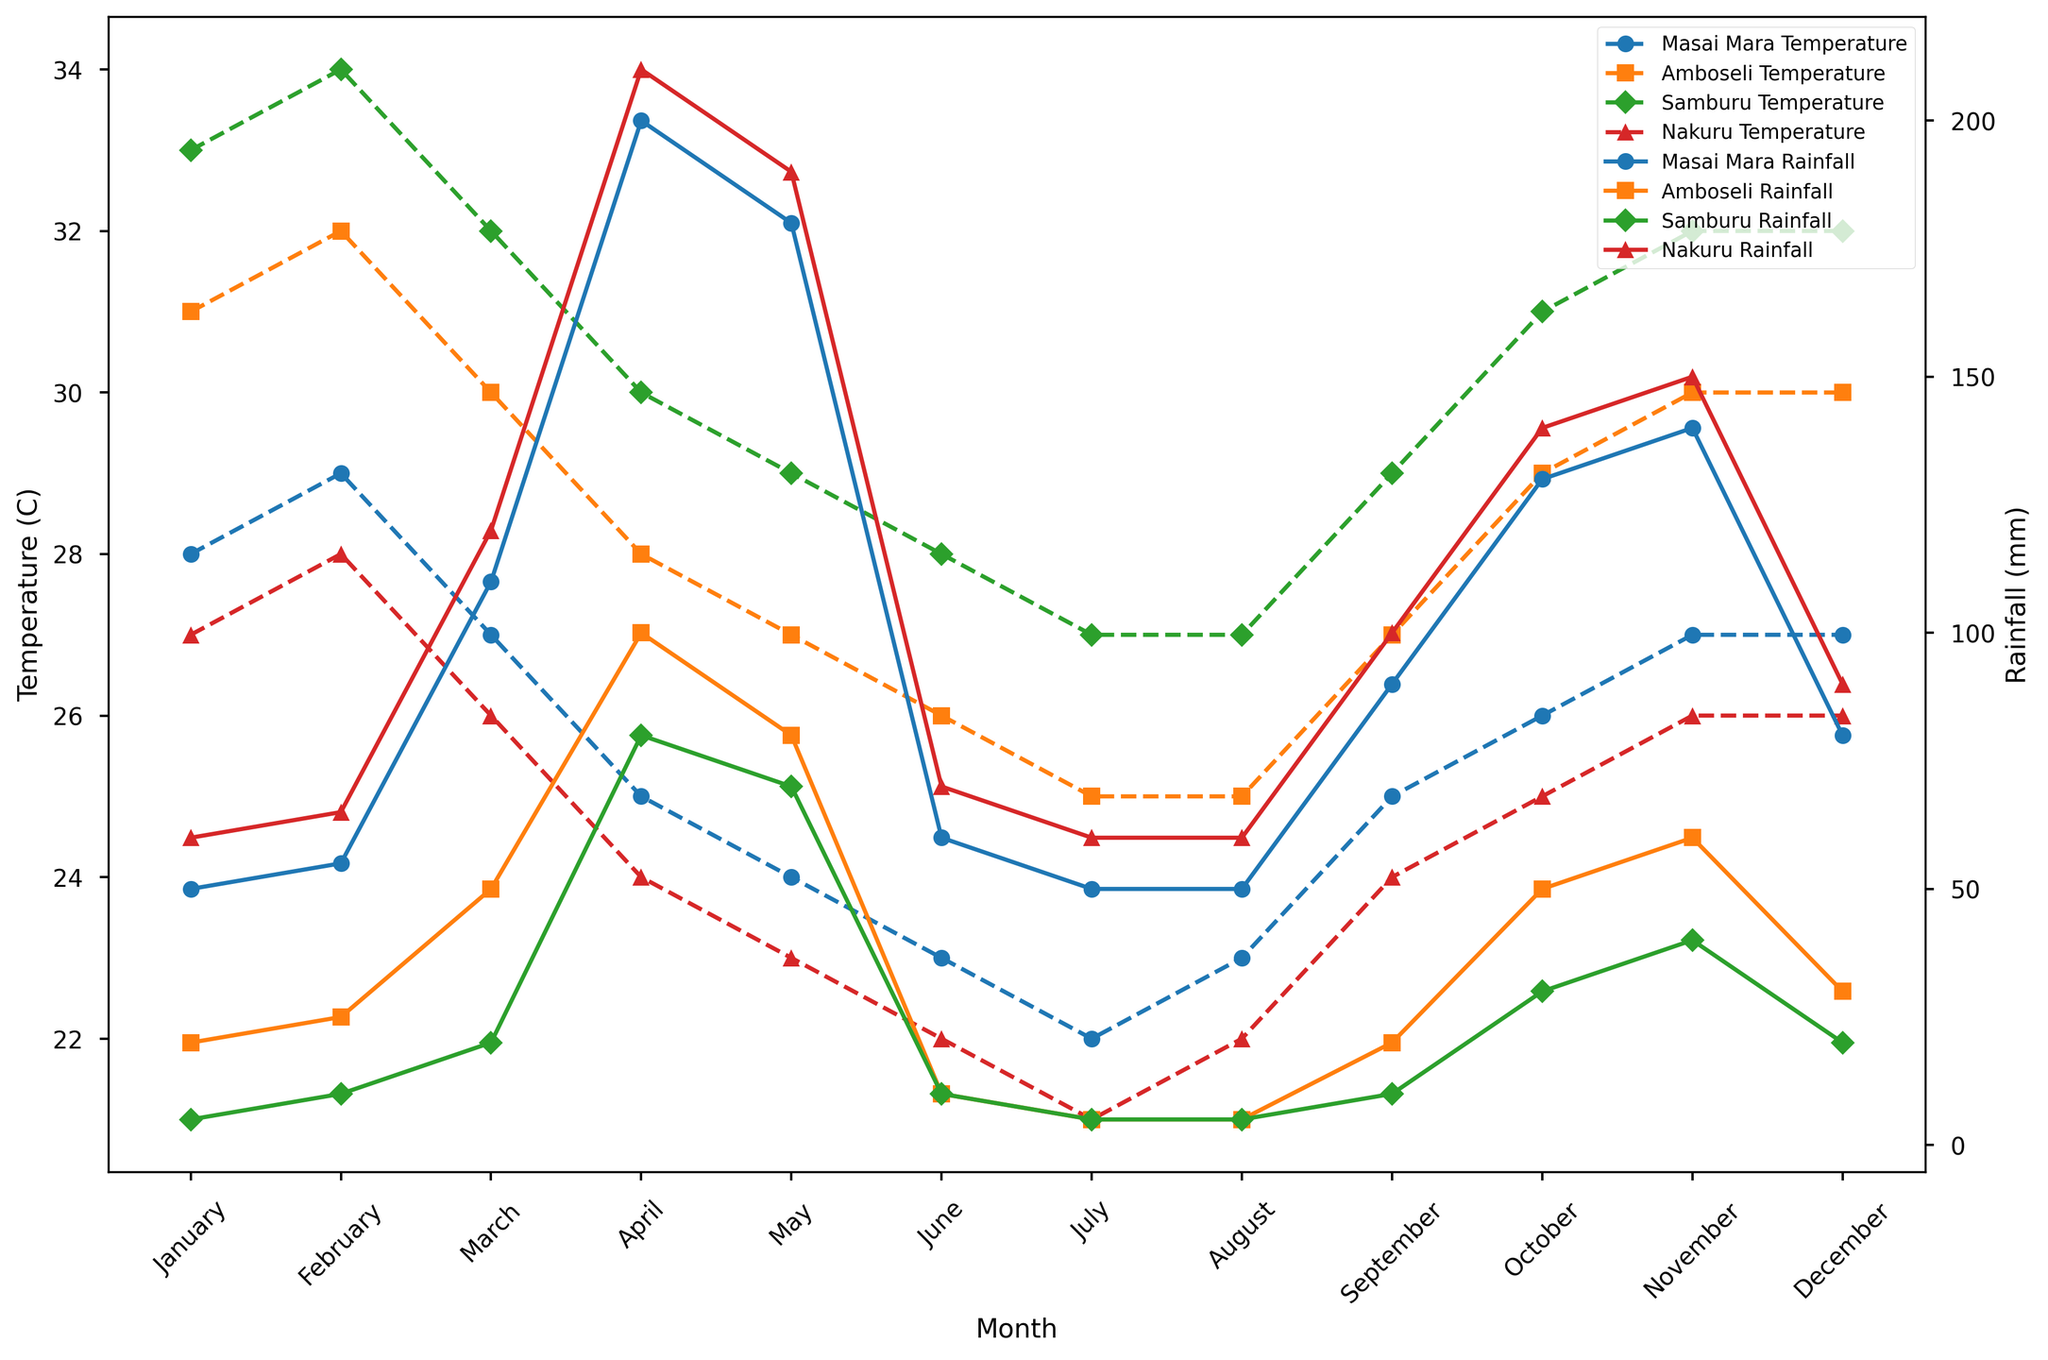What are the highest and lowest temperatures recorded in Masai Mara throughout the year? The highest temperature in Masai Mara is recorded in February at 29°C, and the lowest temperature is recorded in July at 22°C.
Answer: 29°C (highest), 22°C (lowest) Which month has the highest rainfall in Samburu? By observing the green line for Samburu, April has the highest rainfall at 80mm.
Answer: April Comparing June temperatures, which location is the hottest and which is the coolest? Look at June for all locations; Samburu is the hottest at 28°C, and Nakuru is the coolest at 22°C.
Answer: Samburu (hottest), Nakuru (coolest) What is the average rainfall in Amboseli from January to December? Sums up the rainfall values for each month in Amboseli (20 + 25 + 50 + 100 + 80 + 10 + 5 + 5 + 20 + 50 + 60 + 30) = 455mm. The average is 455/12 ≈ 37.92mm.
Answer: ≈ 37.92mm In which month does Nakuru experience the highest temperature and what is it? By observing the red line for Nakuru, February has the highest temperature at 28°C.
Answer: February, 28°C What is the difference in temperature between the hottest and coldest months in Masai Mara? The highest temperature in Masai Mara is 29°C (February) and the lowest is 22°C (July). The difference is 29 - 22 = 7°C.
Answer: 7°C How does the rainfall pattern in Nairobi compare to that in Amboseli during March and April? Comparing March and April, Nairobi has higher rainfall in both months (March: 120mm vs. 50mm, April: 210mm vs. 100mm).
Answer: Nairobi has higher rainfall What trend do you observe in temperatures in Samburu from June to September? The green line indicates temperatures steadily increase from June (28°C) to September (29°C).
Answer: Increasing trend Which month has the same amount of rainfall in both Masai Mara and Nakuru? Observing the lines, January has 50mm of rainfall in both Masai Mara and Nakuru.
Answer: January What is the overall trend in rainfall in Masai Mara over the months? The tab:blue line with dashes shows fluctuations with peaks in April (200mm) and October (130mm), and lower values in other months.
Answer: Fluctuating with peaks in April and October 